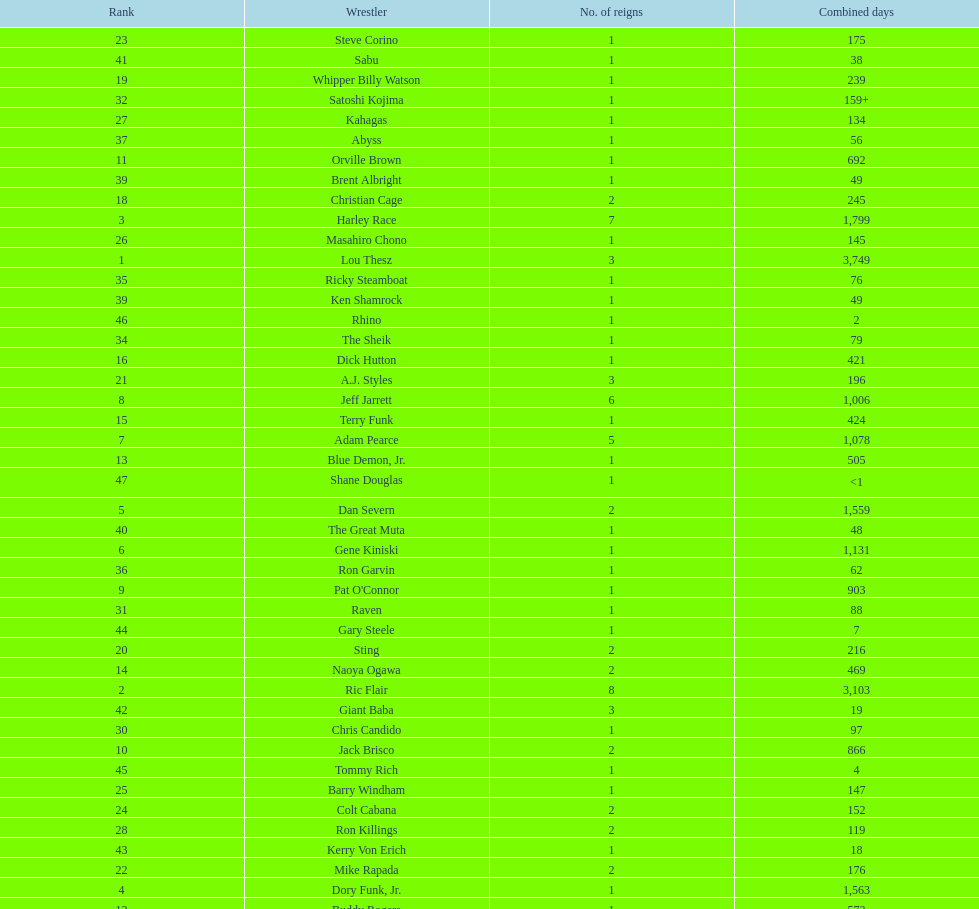How long did orville brown remain nwa world heavyweight champion? 692 days. 